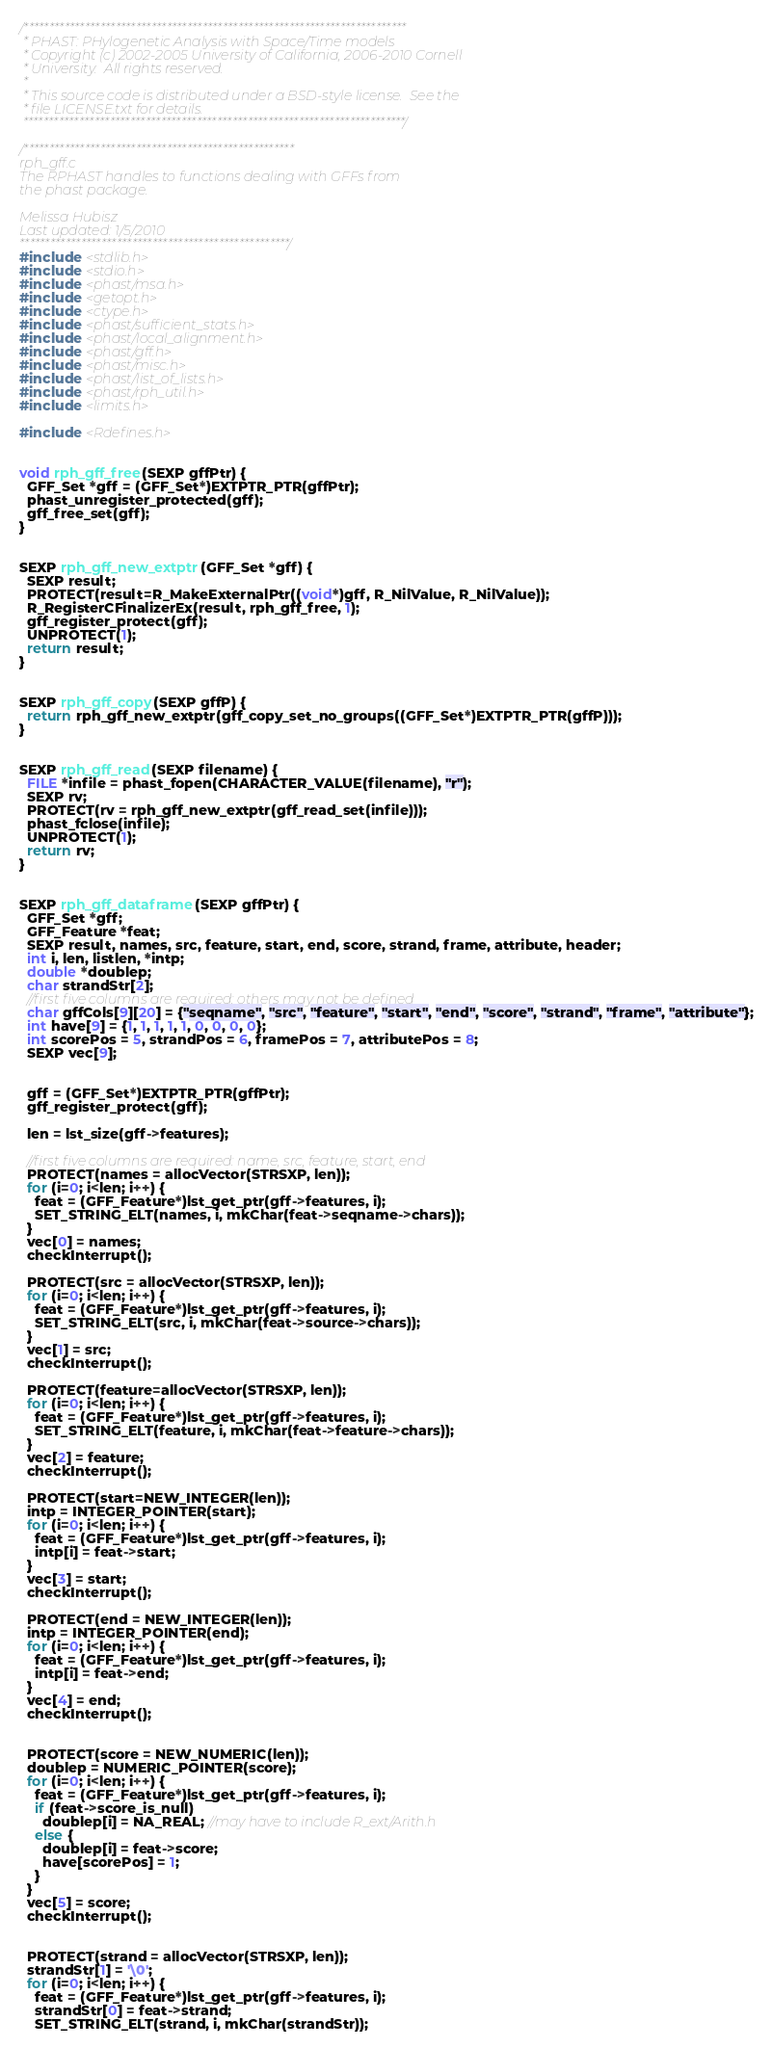<code> <loc_0><loc_0><loc_500><loc_500><_C_>/***************************************************************************
 * PHAST: PHylogenetic Analysis with Space/Time models
 * Copyright (c) 2002-2005 University of California, 2006-2010 Cornell
 * University.  All rights reserved.
 *
 * This source code is distributed under a BSD-style license.  See the
 * file LICENSE.txt for details.
 ***************************************************************************/

/*****************************************************
rph_gff.c
The RPHAST handles to functions dealing with GFFs from
the phast package.

Melissa Hubisz
Last updated: 1/5/2010
*****************************************************/
#include <stdlib.h>
#include <stdio.h>
#include <phast/msa.h>
#include <getopt.h>
#include <ctype.h>
#include <phast/sufficient_stats.h>
#include <phast/local_alignment.h>
#include <phast/gff.h>
#include <phast/misc.h>
#include <phast/list_of_lists.h>
#include <phast/rph_util.h>
#include <limits.h>

#include <Rdefines.h>


void rph_gff_free(SEXP gffPtr) {
  GFF_Set *gff = (GFF_Set*)EXTPTR_PTR(gffPtr);
  phast_unregister_protected(gff);
  gff_free_set(gff);
}


SEXP rph_gff_new_extptr(GFF_Set *gff) {
  SEXP result;
  PROTECT(result=R_MakeExternalPtr((void*)gff, R_NilValue, R_NilValue));
  R_RegisterCFinalizerEx(result, rph_gff_free, 1);
  gff_register_protect(gff);
  UNPROTECT(1);
  return result;
}


SEXP rph_gff_copy(SEXP gffP) {
  return rph_gff_new_extptr(gff_copy_set_no_groups((GFF_Set*)EXTPTR_PTR(gffP)));
}


SEXP rph_gff_read(SEXP filename) {
  FILE *infile = phast_fopen(CHARACTER_VALUE(filename), "r");
  SEXP rv;
  PROTECT(rv = rph_gff_new_extptr(gff_read_set(infile)));
  phast_fclose(infile);
  UNPROTECT(1);
  return rv;
}


SEXP rph_gff_dataframe(SEXP gffPtr) {
  GFF_Set *gff;
  GFF_Feature *feat;
  SEXP result, names, src, feature, start, end, score, strand, frame, attribute, header;
  int i, len, listlen, *intp;
  double *doublep;
  char strandStr[2];
  //first five columns are required; others may not be defined
  char gffCols[9][20] = {"seqname", "src", "feature", "start", "end", "score", "strand", "frame", "attribute"};
  int have[9] = {1, 1, 1, 1, 1, 0, 0, 0, 0};
  int scorePos = 5, strandPos = 6, framePos = 7, attributePos = 8;
  SEXP vec[9];


  gff = (GFF_Set*)EXTPTR_PTR(gffPtr);
  gff_register_protect(gff);

  len = lst_size(gff->features);

  //first five columns are required: name, src, feature, start, end
  PROTECT(names = allocVector(STRSXP, len));
  for (i=0; i<len; i++) {
    feat = (GFF_Feature*)lst_get_ptr(gff->features, i);
    SET_STRING_ELT(names, i, mkChar(feat->seqname->chars));
  }
  vec[0] = names;
  checkInterrupt();

  PROTECT(src = allocVector(STRSXP, len));
  for (i=0; i<len; i++) {
    feat = (GFF_Feature*)lst_get_ptr(gff->features, i);
    SET_STRING_ELT(src, i, mkChar(feat->source->chars));
  }
  vec[1] = src;
  checkInterrupt();

  PROTECT(feature=allocVector(STRSXP, len));
  for (i=0; i<len; i++) {
    feat = (GFF_Feature*)lst_get_ptr(gff->features, i);
    SET_STRING_ELT(feature, i, mkChar(feat->feature->chars));
  }
  vec[2] = feature;
  checkInterrupt();

  PROTECT(start=NEW_INTEGER(len));
  intp = INTEGER_POINTER(start);
  for (i=0; i<len; i++) {
    feat = (GFF_Feature*)lst_get_ptr(gff->features, i);
    intp[i] = feat->start;
  }
  vec[3] = start;
  checkInterrupt();

  PROTECT(end = NEW_INTEGER(len));
  intp = INTEGER_POINTER(end);
  for (i=0; i<len; i++) {
    feat = (GFF_Feature*)lst_get_ptr(gff->features, i);
    intp[i] = feat->end;
  }
  vec[4] = end;
  checkInterrupt();


  PROTECT(score = NEW_NUMERIC(len));
  doublep = NUMERIC_POINTER(score);
  for (i=0; i<len; i++) {
    feat = (GFF_Feature*)lst_get_ptr(gff->features, i);
    if (feat->score_is_null)
      doublep[i] = NA_REAL; //may have to include R_ext/Arith.h
    else {
      doublep[i] = feat->score;
      have[scorePos] = 1;
    }
  }
  vec[5] = score;
  checkInterrupt();


  PROTECT(strand = allocVector(STRSXP, len));
  strandStr[1] = '\0';
  for (i=0; i<len; i++) {
    feat = (GFF_Feature*)lst_get_ptr(gff->features, i);
    strandStr[0] = feat->strand;
    SET_STRING_ELT(strand, i, mkChar(strandStr));</code> 